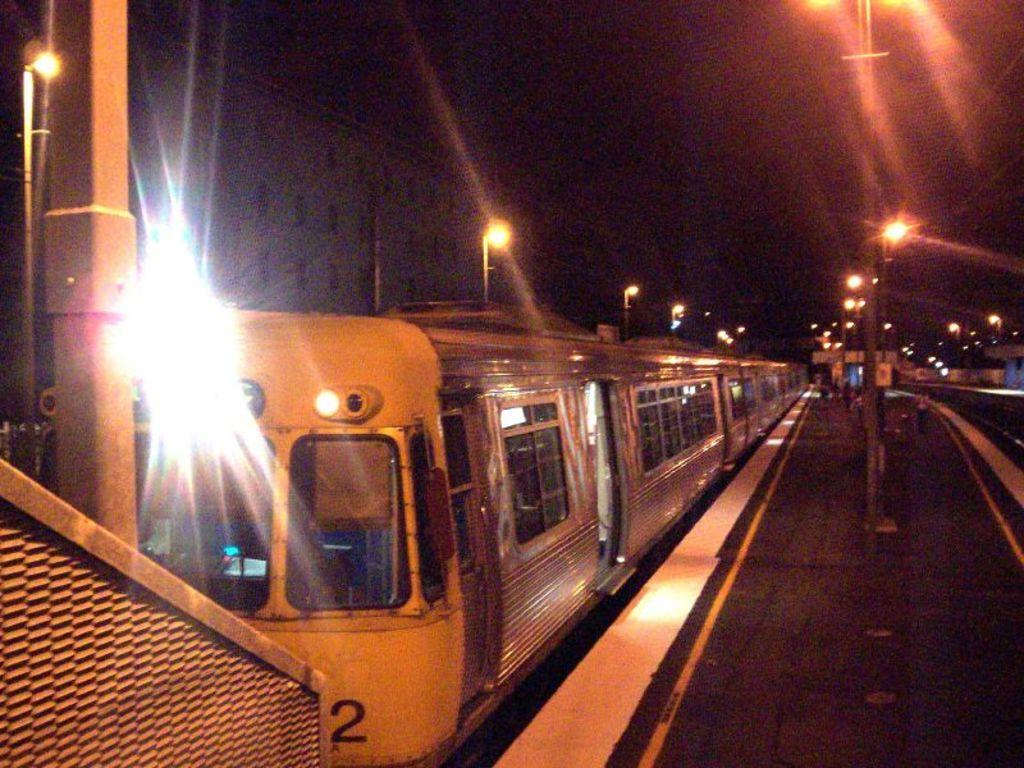<image>
Present a compact description of the photo's key features. a train at a station that has the number 2 on the bottom right front 